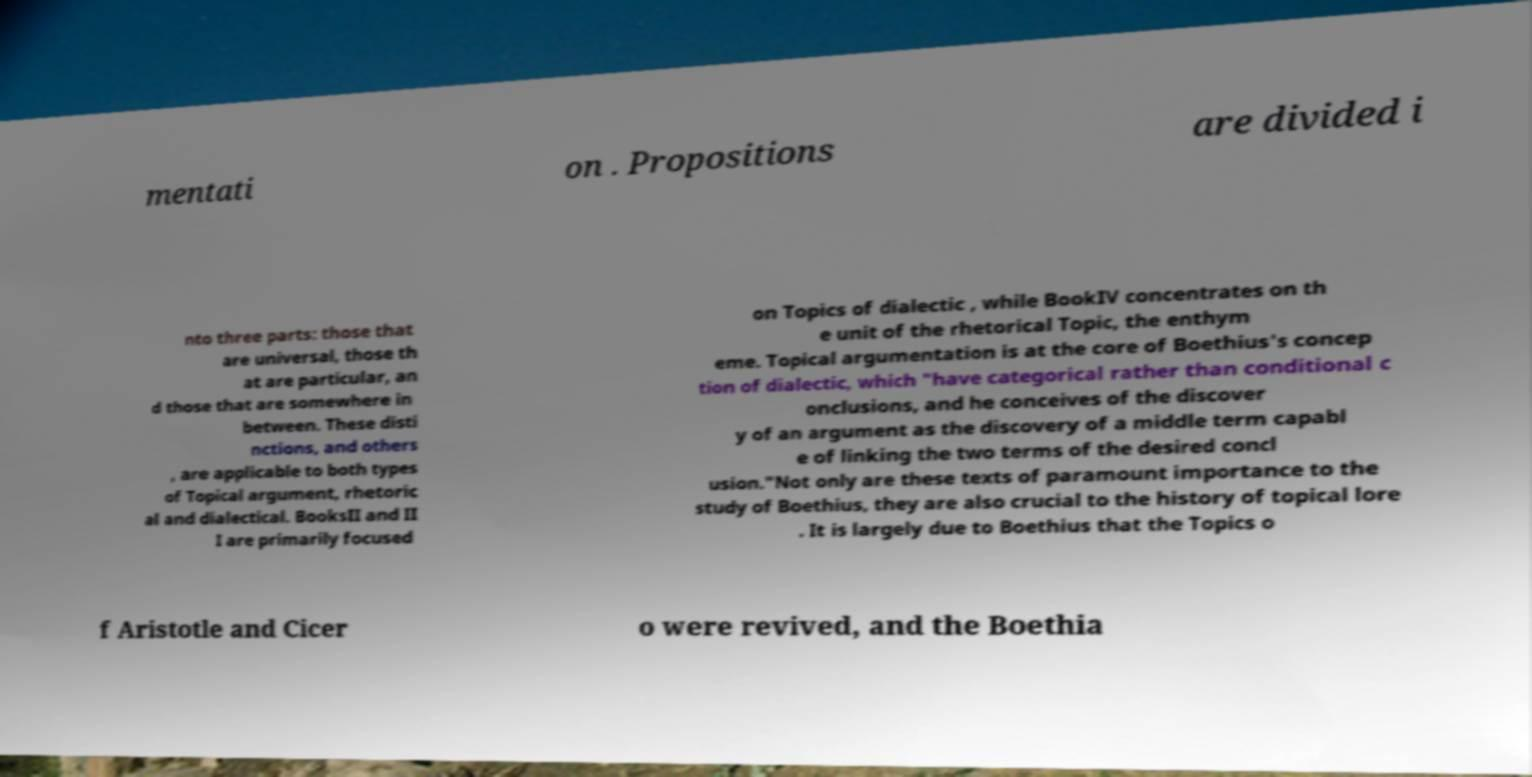Can you accurately transcribe the text from the provided image for me? mentati on . Propositions are divided i nto three parts: those that are universal, those th at are particular, an d those that are somewhere in between. These disti nctions, and others , are applicable to both types of Topical argument, rhetoric al and dialectical. BooksII and II I are primarily focused on Topics of dialectic , while BookIV concentrates on th e unit of the rhetorical Topic, the enthym eme. Topical argumentation is at the core of Boethius's concep tion of dialectic, which "have categorical rather than conditional c onclusions, and he conceives of the discover y of an argument as the discovery of a middle term capabl e of linking the two terms of the desired concl usion."Not only are these texts of paramount importance to the study of Boethius, they are also crucial to the history of topical lore . It is largely due to Boethius that the Topics o f Aristotle and Cicer o were revived, and the Boethia 